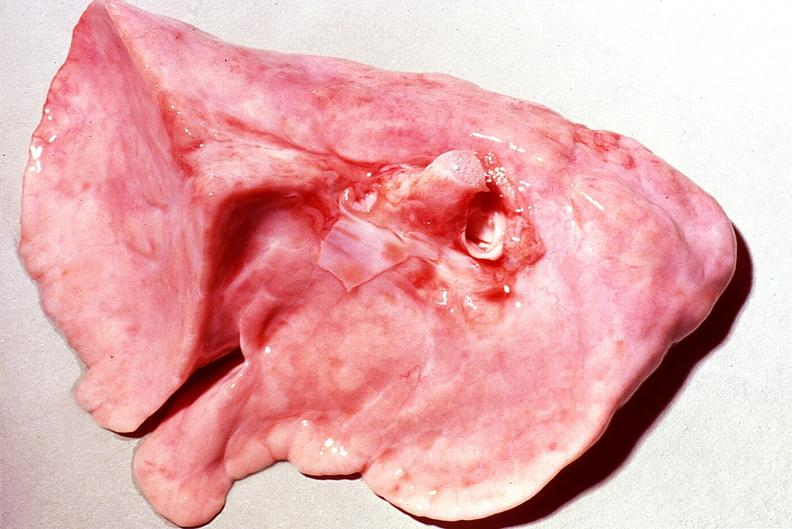what does this image show?
Answer the question using a single word or phrase. Normal lung 